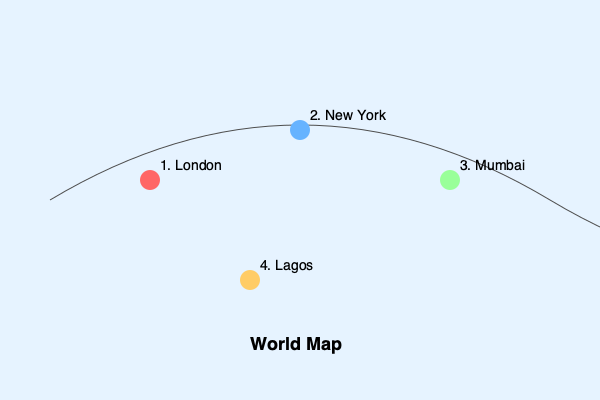In the world map above, which numbered location corresponds to the primary setting of Chimamanda Ngozi Adichie's novel "Americanah"? To answer this question, we need to consider the following steps:

1. Recall that "Americanah" is a realistic fiction novel by Chimamanda Ngozi Adichie.

2. The novel primarily takes place in three locations: Nigeria, the United States, and briefly in the United Kingdom.

3. The story begins and ends in Nigeria, with the protagonist Ifemelu spending a significant portion of her life there.

4. Looking at the map, we can identify the locations:
   1. London (United Kingdom)
   2. New York (United States)
   3. Mumbai (India)
   4. Lagos (Nigeria)

5. Among these options, Lagos (4) is the only city located in Nigeria.

6. While the novel does have scenes set in the United States and the United Kingdom, the heart of the story and its cultural exploration is rooted in Nigeria.

Therefore, the primary setting of "Americanah" corresponds to location 4 on the map, which represents Lagos, Nigeria.
Answer: 4 